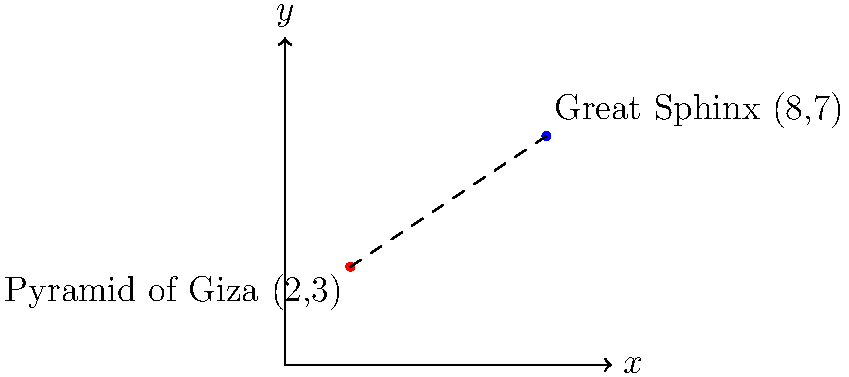In your research on ancient Egyptian landmarks, you've plotted the locations of the Pyramid of Giza and the Great Sphinx on a coordinate plane. The Pyramid of Giza is located at (2,3) and the Great Sphinx at (8,7). Using the distance formula, calculate the distance between these two historical landmarks. Round your answer to two decimal places. To solve this problem, we'll use the distance formula:

$$d = \sqrt{(x_2 - x_1)^2 + (y_2 - y_1)^2}$$

Where $(x_1, y_1)$ is the coordinate of the Pyramid of Giza (2,3) and $(x_2, y_2)$ is the coordinate of the Great Sphinx (8,7).

Step 1: Identify the coordinates
- Pyramid of Giza: $(x_1, y_1) = (2, 3)$
- Great Sphinx: $(x_2, y_2) = (8, 7)$

Step 2: Substitute the values into the distance formula
$$d = \sqrt{(8 - 2)^2 + (7 - 3)^2}$$

Step 3: Simplify the expressions inside the parentheses
$$d = \sqrt{6^2 + 4^2}$$

Step 4: Calculate the squares
$$d = \sqrt{36 + 16}$$

Step 5: Add the values under the square root
$$d = \sqrt{52}$$

Step 6: Calculate the square root and round to two decimal places
$$d \approx 7.21$$

Therefore, the distance between the Pyramid of Giza and the Great Sphinx is approximately 7.21 units.
Answer: 7.21 units 